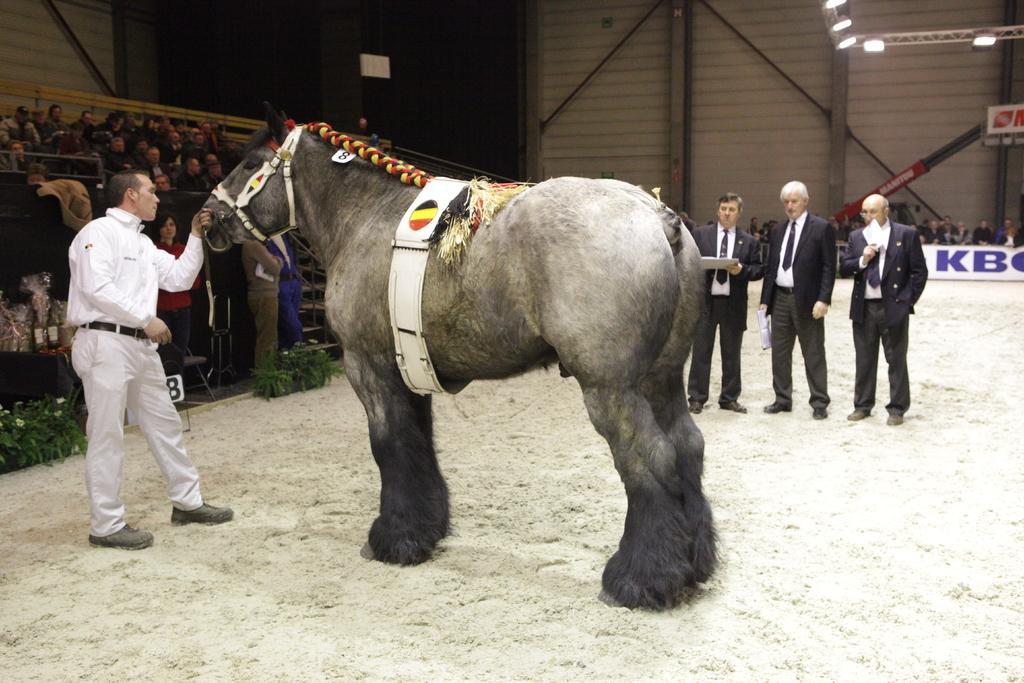Describe this image in one or two sentences. In this image i can see a person holding a animal and 3 other persons watching the animal. In the background i can see few people sitting, the wall and few lights. 